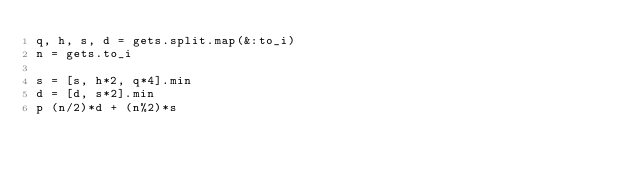Convert code to text. <code><loc_0><loc_0><loc_500><loc_500><_Ruby_>q, h, s, d = gets.split.map(&:to_i)
n = gets.to_i

s = [s, h*2, q*4].min
d = [d, s*2].min
p (n/2)*d + (n%2)*s</code> 